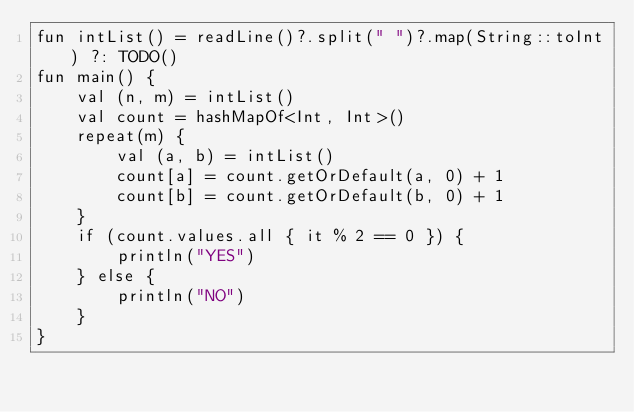<code> <loc_0><loc_0><loc_500><loc_500><_Kotlin_>fun intList() = readLine()?.split(" ")?.map(String::toInt) ?: TODO()
fun main() {
    val (n, m) = intList()
    val count = hashMapOf<Int, Int>()
    repeat(m) {
        val (a, b) = intList()
        count[a] = count.getOrDefault(a, 0) + 1
        count[b] = count.getOrDefault(b, 0) + 1
    }
    if (count.values.all { it % 2 == 0 }) {
        println("YES")
    } else {
        println("NO")
    }
}
</code> 